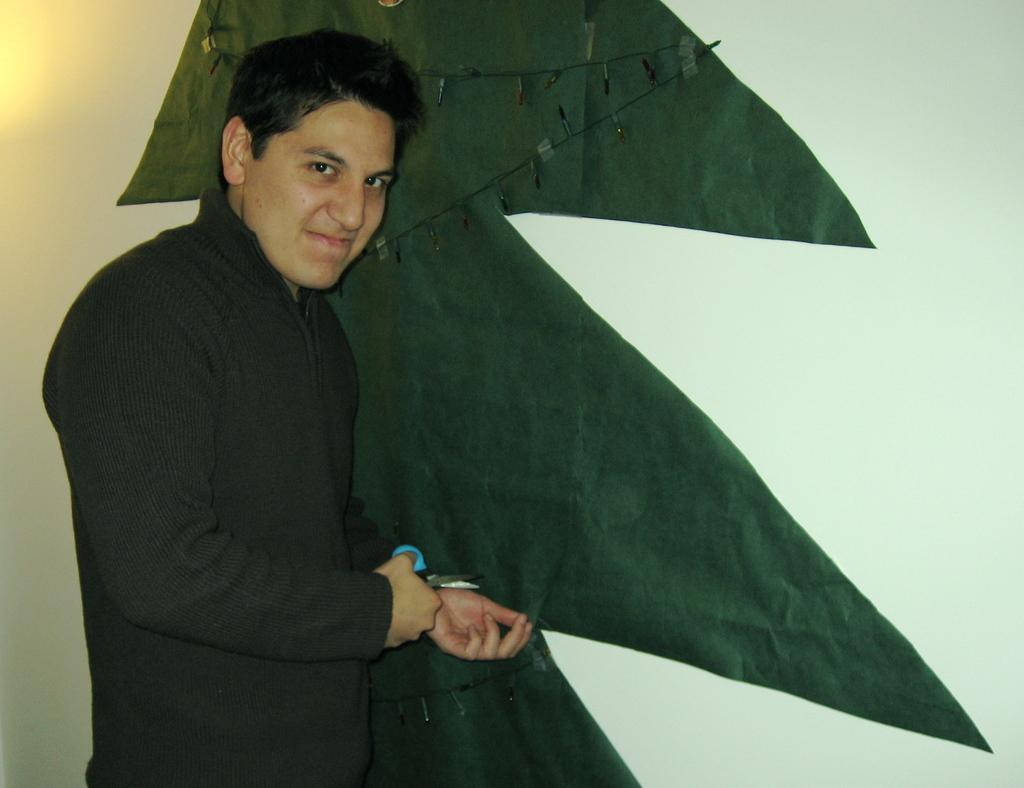What is the main subject of the picture? The main subject of the picture is a boy. What is the boy holding in his hand? The boy is holding a scissor in his hand. What is the boy doing with the scissor? The boy is cutting the shape of a tree. What color is the curtain behind the boy in the picture? There is no curtain present in the image. 